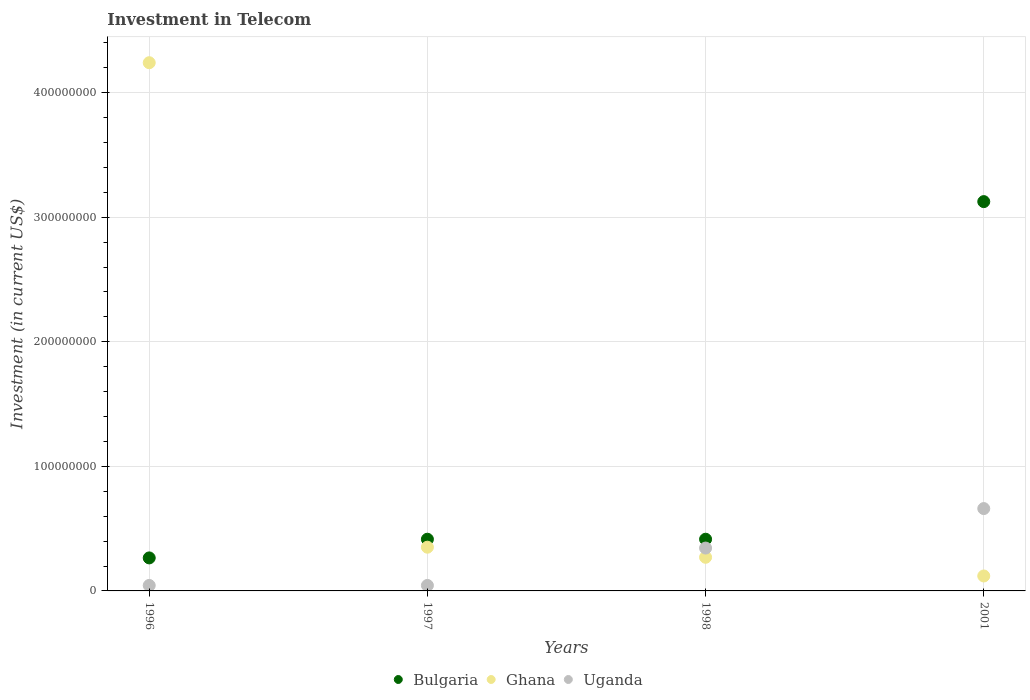What is the amount invested in telecom in Ghana in 1998?
Ensure brevity in your answer.  2.70e+07. Across all years, what is the maximum amount invested in telecom in Bulgaria?
Give a very brief answer. 3.12e+08. Across all years, what is the minimum amount invested in telecom in Ghana?
Give a very brief answer. 1.20e+07. In which year was the amount invested in telecom in Ghana maximum?
Offer a very short reply. 1996. In which year was the amount invested in telecom in Bulgaria minimum?
Your answer should be very brief. 1996. What is the total amount invested in telecom in Uganda in the graph?
Give a very brief answer. 1.09e+08. What is the difference between the amount invested in telecom in Ghana in 1997 and that in 2001?
Ensure brevity in your answer.  2.31e+07. What is the difference between the amount invested in telecom in Ghana in 1998 and the amount invested in telecom in Uganda in 1997?
Your answer should be very brief. 2.26e+07. What is the average amount invested in telecom in Ghana per year?
Your answer should be compact. 1.25e+08. In the year 1997, what is the difference between the amount invested in telecom in Uganda and amount invested in telecom in Ghana?
Your response must be concise. -3.07e+07. In how many years, is the amount invested in telecom in Ghana greater than 20000000 US$?
Provide a short and direct response. 3. What is the ratio of the amount invested in telecom in Uganda in 1996 to that in 1998?
Your response must be concise. 0.13. Is the difference between the amount invested in telecom in Uganda in 1998 and 2001 greater than the difference between the amount invested in telecom in Ghana in 1998 and 2001?
Offer a very short reply. No. What is the difference between the highest and the second highest amount invested in telecom in Ghana?
Your answer should be compact. 3.89e+08. What is the difference between the highest and the lowest amount invested in telecom in Ghana?
Ensure brevity in your answer.  4.12e+08. Is the sum of the amount invested in telecom in Uganda in 1997 and 2001 greater than the maximum amount invested in telecom in Bulgaria across all years?
Make the answer very short. No. Is the amount invested in telecom in Uganda strictly greater than the amount invested in telecom in Ghana over the years?
Provide a succinct answer. No. How many years are there in the graph?
Your answer should be compact. 4. Does the graph contain grids?
Your answer should be compact. Yes. What is the title of the graph?
Keep it short and to the point. Investment in Telecom. Does "Honduras" appear as one of the legend labels in the graph?
Your answer should be very brief. No. What is the label or title of the X-axis?
Your answer should be compact. Years. What is the label or title of the Y-axis?
Ensure brevity in your answer.  Investment (in current US$). What is the Investment (in current US$) of Bulgaria in 1996?
Ensure brevity in your answer.  2.65e+07. What is the Investment (in current US$) of Ghana in 1996?
Give a very brief answer. 4.24e+08. What is the Investment (in current US$) of Uganda in 1996?
Provide a short and direct response. 4.40e+06. What is the Investment (in current US$) in Bulgaria in 1997?
Your answer should be very brief. 4.15e+07. What is the Investment (in current US$) in Ghana in 1997?
Make the answer very short. 3.51e+07. What is the Investment (in current US$) in Uganda in 1997?
Provide a succinct answer. 4.40e+06. What is the Investment (in current US$) of Bulgaria in 1998?
Give a very brief answer. 4.15e+07. What is the Investment (in current US$) in Ghana in 1998?
Your answer should be very brief. 2.70e+07. What is the Investment (in current US$) of Uganda in 1998?
Your answer should be very brief. 3.44e+07. What is the Investment (in current US$) of Bulgaria in 2001?
Ensure brevity in your answer.  3.12e+08. What is the Investment (in current US$) in Uganda in 2001?
Give a very brief answer. 6.61e+07. Across all years, what is the maximum Investment (in current US$) of Bulgaria?
Your response must be concise. 3.12e+08. Across all years, what is the maximum Investment (in current US$) in Ghana?
Your answer should be very brief. 4.24e+08. Across all years, what is the maximum Investment (in current US$) of Uganda?
Your answer should be compact. 6.61e+07. Across all years, what is the minimum Investment (in current US$) of Bulgaria?
Your answer should be very brief. 2.65e+07. Across all years, what is the minimum Investment (in current US$) of Uganda?
Your answer should be very brief. 4.40e+06. What is the total Investment (in current US$) in Bulgaria in the graph?
Make the answer very short. 4.22e+08. What is the total Investment (in current US$) of Ghana in the graph?
Make the answer very short. 4.98e+08. What is the total Investment (in current US$) of Uganda in the graph?
Offer a very short reply. 1.09e+08. What is the difference between the Investment (in current US$) of Bulgaria in 1996 and that in 1997?
Your response must be concise. -1.50e+07. What is the difference between the Investment (in current US$) of Ghana in 1996 and that in 1997?
Provide a short and direct response. 3.89e+08. What is the difference between the Investment (in current US$) of Uganda in 1996 and that in 1997?
Make the answer very short. 0. What is the difference between the Investment (in current US$) in Bulgaria in 1996 and that in 1998?
Provide a succinct answer. -1.50e+07. What is the difference between the Investment (in current US$) in Ghana in 1996 and that in 1998?
Ensure brevity in your answer.  3.97e+08. What is the difference between the Investment (in current US$) in Uganda in 1996 and that in 1998?
Keep it short and to the point. -3.00e+07. What is the difference between the Investment (in current US$) of Bulgaria in 1996 and that in 2001?
Offer a very short reply. -2.86e+08. What is the difference between the Investment (in current US$) in Ghana in 1996 and that in 2001?
Your response must be concise. 4.12e+08. What is the difference between the Investment (in current US$) of Uganda in 1996 and that in 2001?
Your answer should be very brief. -6.17e+07. What is the difference between the Investment (in current US$) of Bulgaria in 1997 and that in 1998?
Give a very brief answer. 0. What is the difference between the Investment (in current US$) of Ghana in 1997 and that in 1998?
Offer a very short reply. 8.10e+06. What is the difference between the Investment (in current US$) of Uganda in 1997 and that in 1998?
Give a very brief answer. -3.00e+07. What is the difference between the Investment (in current US$) of Bulgaria in 1997 and that in 2001?
Your answer should be compact. -2.71e+08. What is the difference between the Investment (in current US$) of Ghana in 1997 and that in 2001?
Ensure brevity in your answer.  2.31e+07. What is the difference between the Investment (in current US$) in Uganda in 1997 and that in 2001?
Your answer should be compact. -6.17e+07. What is the difference between the Investment (in current US$) in Bulgaria in 1998 and that in 2001?
Provide a short and direct response. -2.71e+08. What is the difference between the Investment (in current US$) in Ghana in 1998 and that in 2001?
Provide a short and direct response. 1.50e+07. What is the difference between the Investment (in current US$) in Uganda in 1998 and that in 2001?
Your response must be concise. -3.17e+07. What is the difference between the Investment (in current US$) in Bulgaria in 1996 and the Investment (in current US$) in Ghana in 1997?
Offer a terse response. -8.60e+06. What is the difference between the Investment (in current US$) in Bulgaria in 1996 and the Investment (in current US$) in Uganda in 1997?
Give a very brief answer. 2.21e+07. What is the difference between the Investment (in current US$) in Ghana in 1996 and the Investment (in current US$) in Uganda in 1997?
Your response must be concise. 4.20e+08. What is the difference between the Investment (in current US$) in Bulgaria in 1996 and the Investment (in current US$) in Ghana in 1998?
Provide a succinct answer. -5.00e+05. What is the difference between the Investment (in current US$) in Bulgaria in 1996 and the Investment (in current US$) in Uganda in 1998?
Provide a short and direct response. -7.90e+06. What is the difference between the Investment (in current US$) in Ghana in 1996 and the Investment (in current US$) in Uganda in 1998?
Keep it short and to the point. 3.90e+08. What is the difference between the Investment (in current US$) in Bulgaria in 1996 and the Investment (in current US$) in Ghana in 2001?
Your response must be concise. 1.45e+07. What is the difference between the Investment (in current US$) of Bulgaria in 1996 and the Investment (in current US$) of Uganda in 2001?
Make the answer very short. -3.96e+07. What is the difference between the Investment (in current US$) of Ghana in 1996 and the Investment (in current US$) of Uganda in 2001?
Your answer should be compact. 3.58e+08. What is the difference between the Investment (in current US$) of Bulgaria in 1997 and the Investment (in current US$) of Ghana in 1998?
Provide a succinct answer. 1.45e+07. What is the difference between the Investment (in current US$) of Bulgaria in 1997 and the Investment (in current US$) of Uganda in 1998?
Offer a very short reply. 7.10e+06. What is the difference between the Investment (in current US$) in Bulgaria in 1997 and the Investment (in current US$) in Ghana in 2001?
Keep it short and to the point. 2.95e+07. What is the difference between the Investment (in current US$) of Bulgaria in 1997 and the Investment (in current US$) of Uganda in 2001?
Your response must be concise. -2.46e+07. What is the difference between the Investment (in current US$) of Ghana in 1997 and the Investment (in current US$) of Uganda in 2001?
Keep it short and to the point. -3.10e+07. What is the difference between the Investment (in current US$) in Bulgaria in 1998 and the Investment (in current US$) in Ghana in 2001?
Your answer should be very brief. 2.95e+07. What is the difference between the Investment (in current US$) in Bulgaria in 1998 and the Investment (in current US$) in Uganda in 2001?
Ensure brevity in your answer.  -2.46e+07. What is the difference between the Investment (in current US$) of Ghana in 1998 and the Investment (in current US$) of Uganda in 2001?
Give a very brief answer. -3.91e+07. What is the average Investment (in current US$) of Bulgaria per year?
Make the answer very short. 1.06e+08. What is the average Investment (in current US$) in Ghana per year?
Ensure brevity in your answer.  1.25e+08. What is the average Investment (in current US$) in Uganda per year?
Your response must be concise. 2.73e+07. In the year 1996, what is the difference between the Investment (in current US$) in Bulgaria and Investment (in current US$) in Ghana?
Your answer should be very brief. -3.98e+08. In the year 1996, what is the difference between the Investment (in current US$) of Bulgaria and Investment (in current US$) of Uganda?
Provide a short and direct response. 2.21e+07. In the year 1996, what is the difference between the Investment (in current US$) in Ghana and Investment (in current US$) in Uganda?
Offer a very short reply. 4.20e+08. In the year 1997, what is the difference between the Investment (in current US$) in Bulgaria and Investment (in current US$) in Ghana?
Offer a very short reply. 6.40e+06. In the year 1997, what is the difference between the Investment (in current US$) of Bulgaria and Investment (in current US$) of Uganda?
Offer a very short reply. 3.71e+07. In the year 1997, what is the difference between the Investment (in current US$) of Ghana and Investment (in current US$) of Uganda?
Your answer should be compact. 3.07e+07. In the year 1998, what is the difference between the Investment (in current US$) of Bulgaria and Investment (in current US$) of Ghana?
Give a very brief answer. 1.45e+07. In the year 1998, what is the difference between the Investment (in current US$) of Bulgaria and Investment (in current US$) of Uganda?
Offer a terse response. 7.10e+06. In the year 1998, what is the difference between the Investment (in current US$) of Ghana and Investment (in current US$) of Uganda?
Make the answer very short. -7.40e+06. In the year 2001, what is the difference between the Investment (in current US$) in Bulgaria and Investment (in current US$) in Ghana?
Your response must be concise. 3.00e+08. In the year 2001, what is the difference between the Investment (in current US$) of Bulgaria and Investment (in current US$) of Uganda?
Ensure brevity in your answer.  2.46e+08. In the year 2001, what is the difference between the Investment (in current US$) of Ghana and Investment (in current US$) of Uganda?
Offer a terse response. -5.41e+07. What is the ratio of the Investment (in current US$) in Bulgaria in 1996 to that in 1997?
Give a very brief answer. 0.64. What is the ratio of the Investment (in current US$) of Ghana in 1996 to that in 1997?
Offer a very short reply. 12.08. What is the ratio of the Investment (in current US$) of Bulgaria in 1996 to that in 1998?
Ensure brevity in your answer.  0.64. What is the ratio of the Investment (in current US$) of Ghana in 1996 to that in 1998?
Keep it short and to the point. 15.7. What is the ratio of the Investment (in current US$) in Uganda in 1996 to that in 1998?
Offer a very short reply. 0.13. What is the ratio of the Investment (in current US$) of Bulgaria in 1996 to that in 2001?
Provide a succinct answer. 0.08. What is the ratio of the Investment (in current US$) in Ghana in 1996 to that in 2001?
Provide a succinct answer. 35.33. What is the ratio of the Investment (in current US$) of Uganda in 1996 to that in 2001?
Ensure brevity in your answer.  0.07. What is the ratio of the Investment (in current US$) of Bulgaria in 1997 to that in 1998?
Offer a terse response. 1. What is the ratio of the Investment (in current US$) in Ghana in 1997 to that in 1998?
Your answer should be very brief. 1.3. What is the ratio of the Investment (in current US$) of Uganda in 1997 to that in 1998?
Your answer should be compact. 0.13. What is the ratio of the Investment (in current US$) of Bulgaria in 1997 to that in 2001?
Keep it short and to the point. 0.13. What is the ratio of the Investment (in current US$) in Ghana in 1997 to that in 2001?
Your answer should be compact. 2.92. What is the ratio of the Investment (in current US$) in Uganda in 1997 to that in 2001?
Provide a short and direct response. 0.07. What is the ratio of the Investment (in current US$) in Bulgaria in 1998 to that in 2001?
Provide a succinct answer. 0.13. What is the ratio of the Investment (in current US$) in Ghana in 1998 to that in 2001?
Your response must be concise. 2.25. What is the ratio of the Investment (in current US$) of Uganda in 1998 to that in 2001?
Your answer should be compact. 0.52. What is the difference between the highest and the second highest Investment (in current US$) in Bulgaria?
Ensure brevity in your answer.  2.71e+08. What is the difference between the highest and the second highest Investment (in current US$) of Ghana?
Offer a terse response. 3.89e+08. What is the difference between the highest and the second highest Investment (in current US$) in Uganda?
Offer a terse response. 3.17e+07. What is the difference between the highest and the lowest Investment (in current US$) in Bulgaria?
Ensure brevity in your answer.  2.86e+08. What is the difference between the highest and the lowest Investment (in current US$) of Ghana?
Your response must be concise. 4.12e+08. What is the difference between the highest and the lowest Investment (in current US$) of Uganda?
Keep it short and to the point. 6.17e+07. 